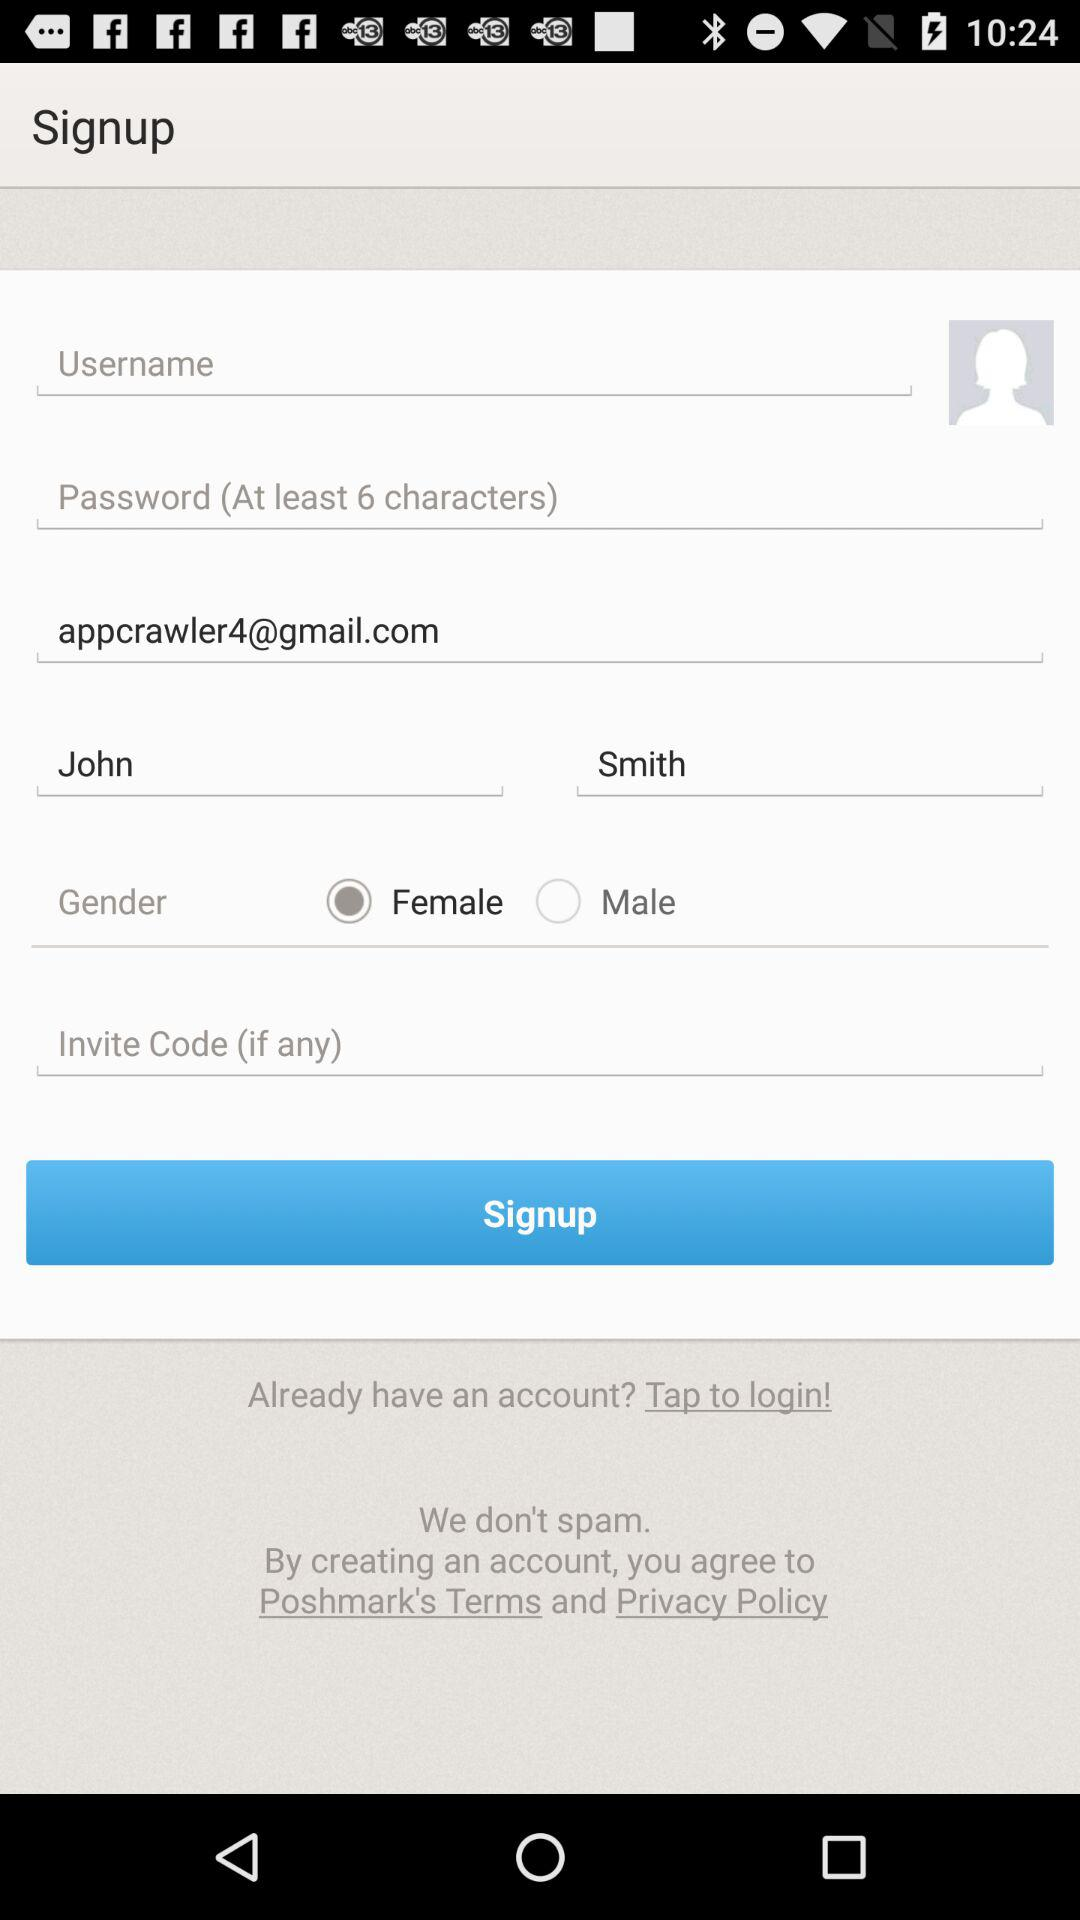What is the minimum number of characters required in a password? The minimum number of characters required in a password is 6. 